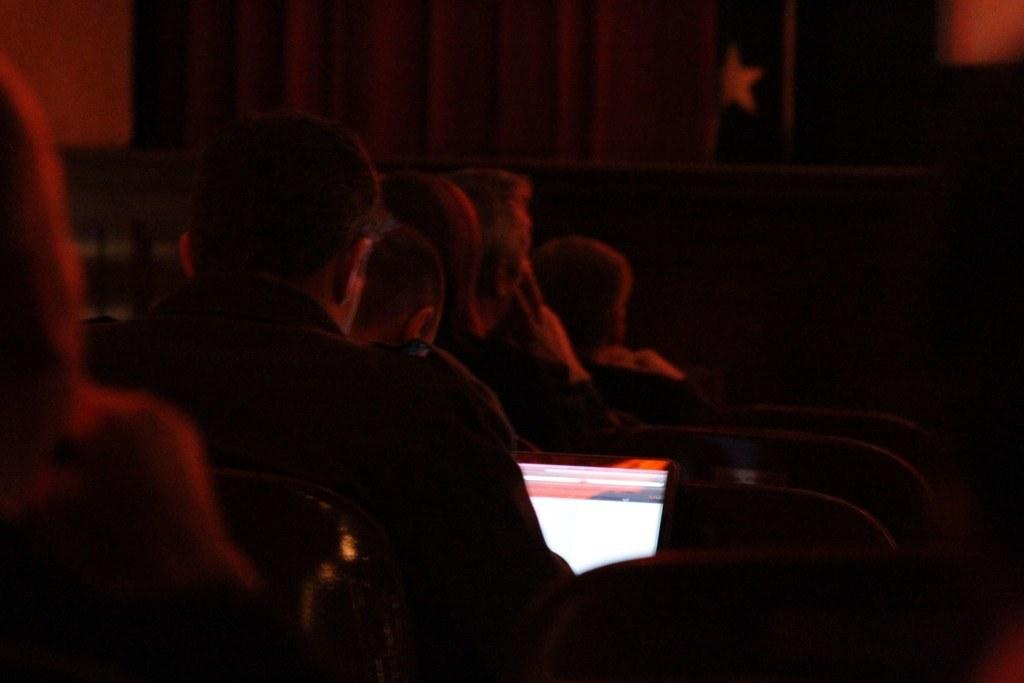What are the people in the image doing? The people in the image are sitting on chairs. Is anyone using a device in the image? Yes, one person is working on a laptop in the image. What type of pen is the person using to write on the desk in the image? There is no pen or desk present in the image; the person is working on a laptop. 